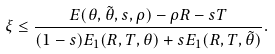<formula> <loc_0><loc_0><loc_500><loc_500>\xi \leq \frac { E ( \theta , \tilde { \theta } , s , \rho ) - \rho R - s T } { ( 1 - s ) E _ { 1 } ( R , T , \theta ) + s E _ { 1 } ( R , T , \tilde { \theta } ) } .</formula> 